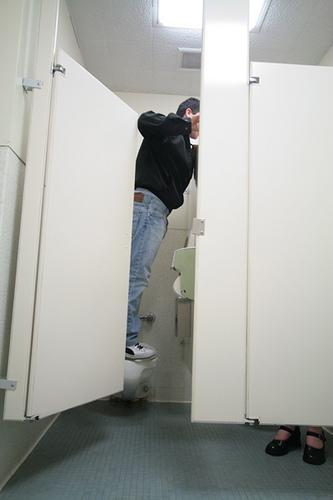How many men are in the picture?
Give a very brief answer. 1. 